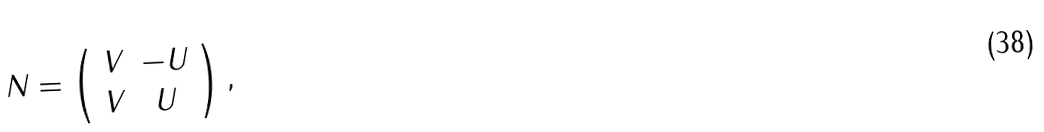Convert formula to latex. <formula><loc_0><loc_0><loc_500><loc_500>N = \left ( \begin{array} { c c } V & - U \\ V & U \end{array} \right ) ,</formula> 